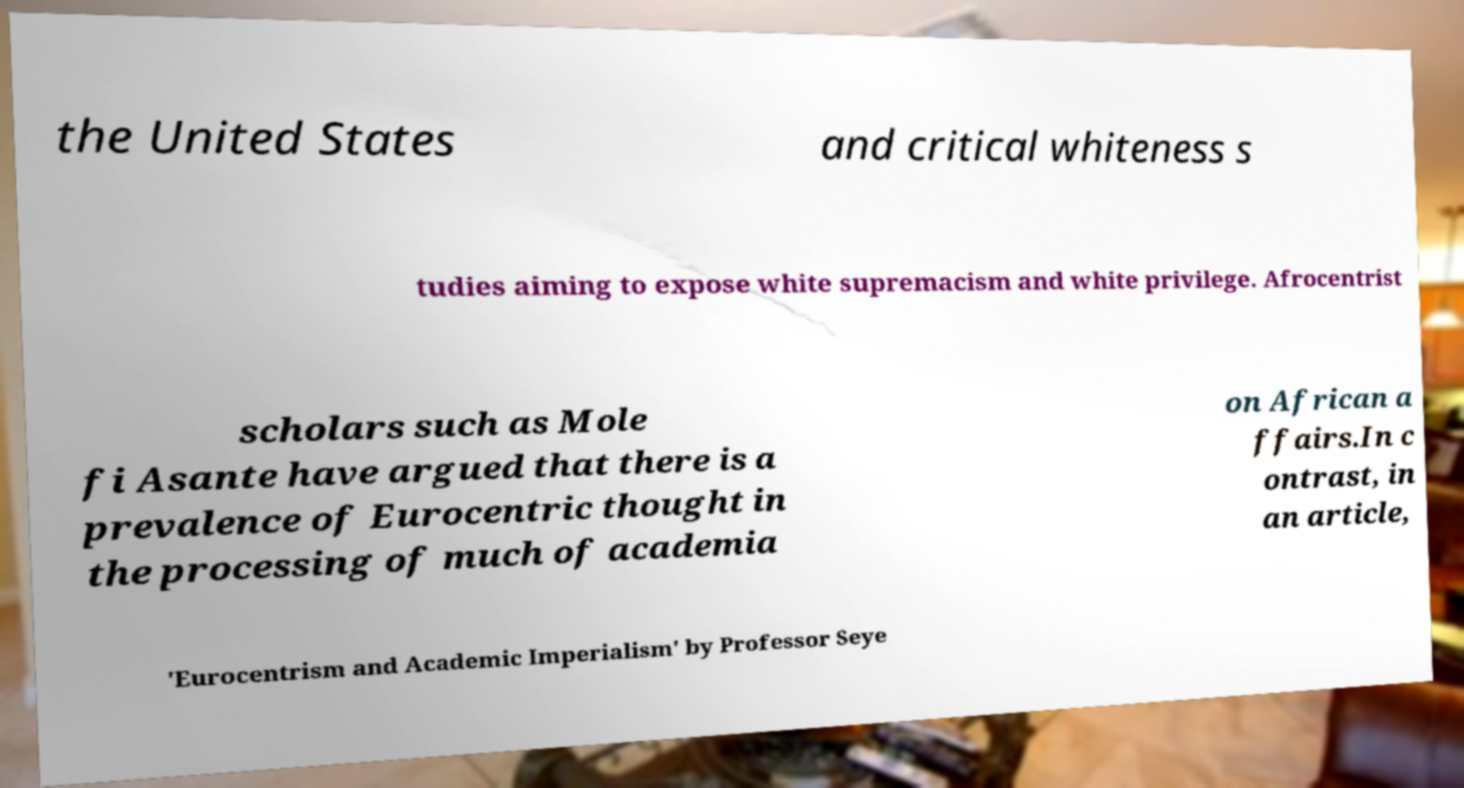Could you extract and type out the text from this image? the United States and critical whiteness s tudies aiming to expose white supremacism and white privilege. Afrocentrist scholars such as Mole fi Asante have argued that there is a prevalence of Eurocentric thought in the processing of much of academia on African a ffairs.In c ontrast, in an article, 'Eurocentrism and Academic Imperialism' by Professor Seye 